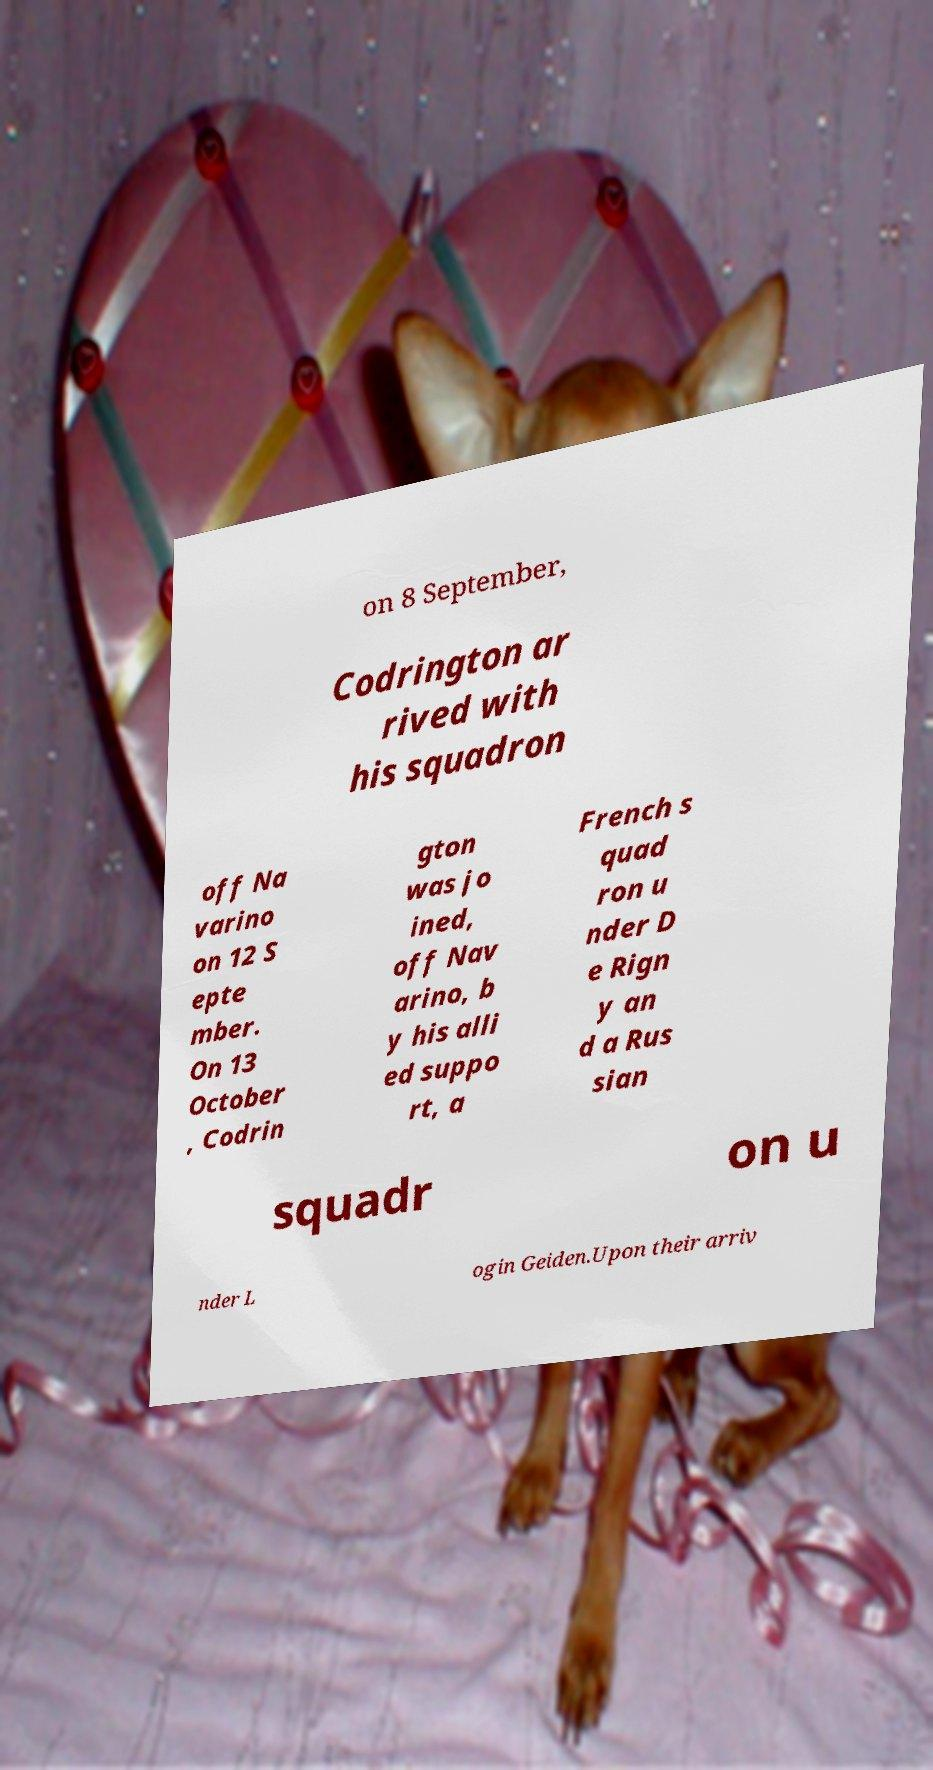What messages or text are displayed in this image? I need them in a readable, typed format. on 8 September, Codrington ar rived with his squadron off Na varino on 12 S epte mber. On 13 October , Codrin gton was jo ined, off Nav arino, b y his alli ed suppo rt, a French s quad ron u nder D e Rign y an d a Rus sian squadr on u nder L ogin Geiden.Upon their arriv 